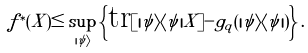<formula> <loc_0><loc_0><loc_500><loc_500>f ^ { \ast } ( X ) \leq \sup _ { | \psi \rangle } \left \{ \text {tr} [ | \psi \rangle \langle \psi | X ] - g _ { q } ( | \psi \rangle \langle \psi | ) \right \} .</formula> 